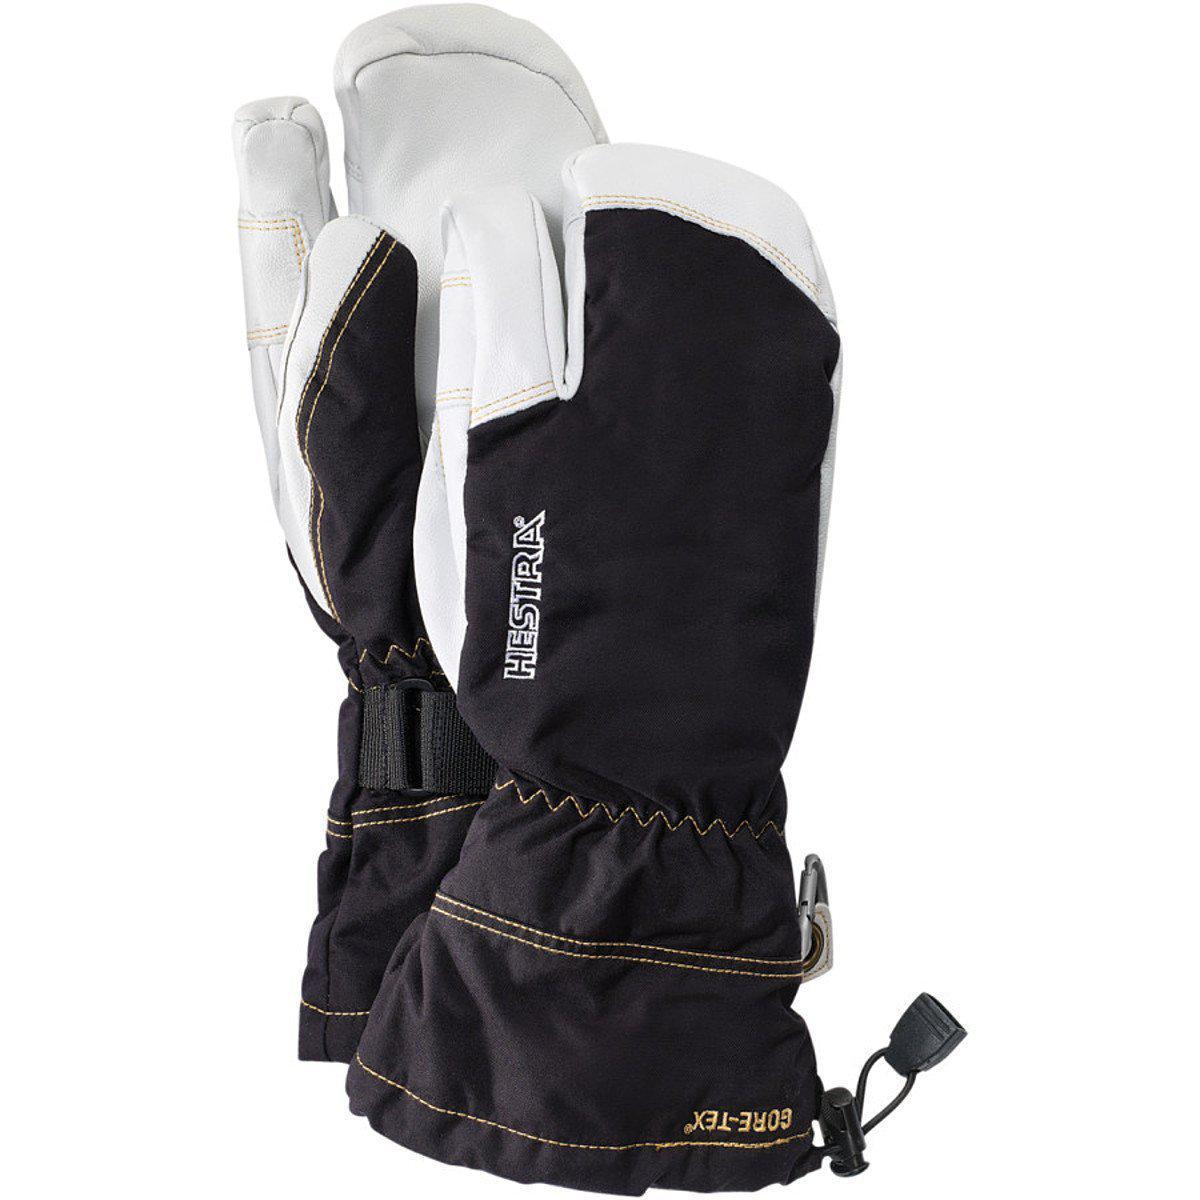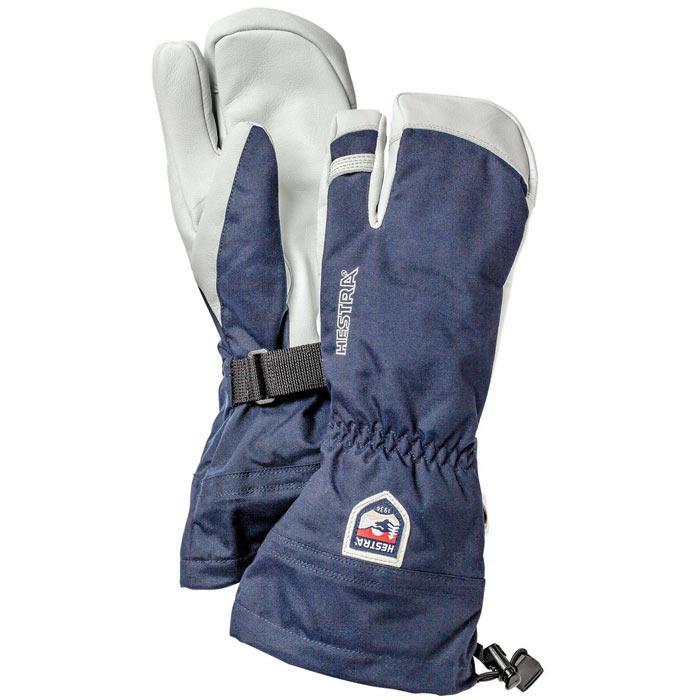The first image is the image on the left, the second image is the image on the right. Given the left and right images, does the statement "There is a pair of brown leather mittens in one of the images." hold true? Answer yes or no. No. The first image is the image on the left, the second image is the image on the right. Given the left and right images, does the statement "Every mitten has a white tip and palm." hold true? Answer yes or no. Yes. 